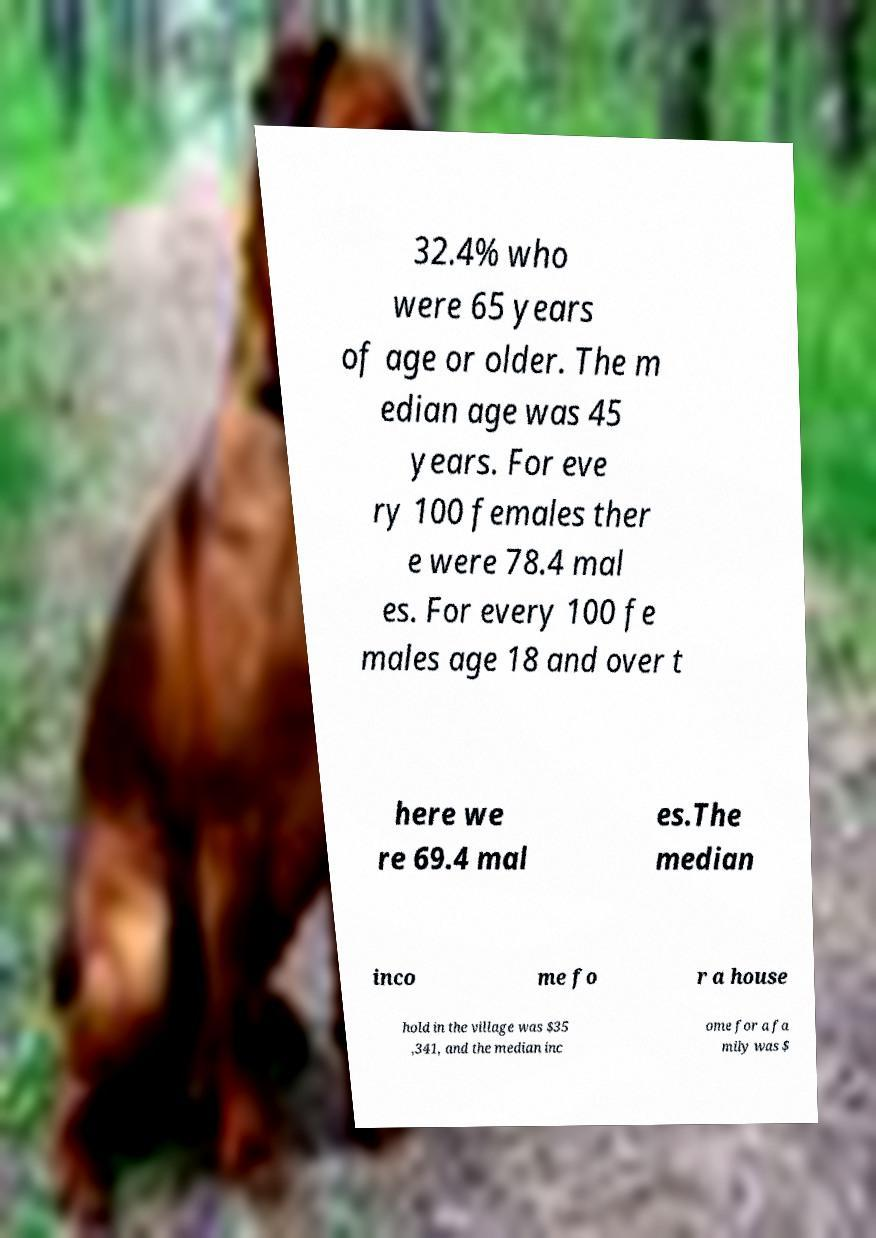Please read and relay the text visible in this image. What does it say? 32.4% who were 65 years of age or older. The m edian age was 45 years. For eve ry 100 females ther e were 78.4 mal es. For every 100 fe males age 18 and over t here we re 69.4 mal es.The median inco me fo r a house hold in the village was $35 ,341, and the median inc ome for a fa mily was $ 